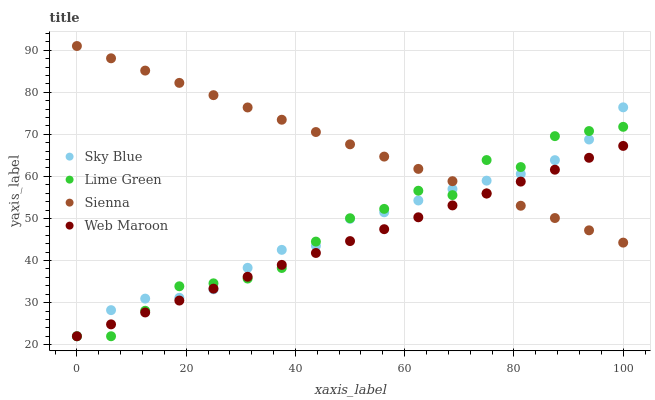Does Web Maroon have the minimum area under the curve?
Answer yes or no. Yes. Does Sienna have the maximum area under the curve?
Answer yes or no. Yes. Does Sky Blue have the minimum area under the curve?
Answer yes or no. No. Does Sky Blue have the maximum area under the curve?
Answer yes or no. No. Is Sienna the smoothest?
Answer yes or no. Yes. Is Lime Green the roughest?
Answer yes or no. Yes. Is Sky Blue the smoothest?
Answer yes or no. No. Is Sky Blue the roughest?
Answer yes or no. No. Does Sky Blue have the lowest value?
Answer yes or no. Yes. Does Sienna have the highest value?
Answer yes or no. Yes. Does Sky Blue have the highest value?
Answer yes or no. No. Does Lime Green intersect Sky Blue?
Answer yes or no. Yes. Is Lime Green less than Sky Blue?
Answer yes or no. No. Is Lime Green greater than Sky Blue?
Answer yes or no. No. 